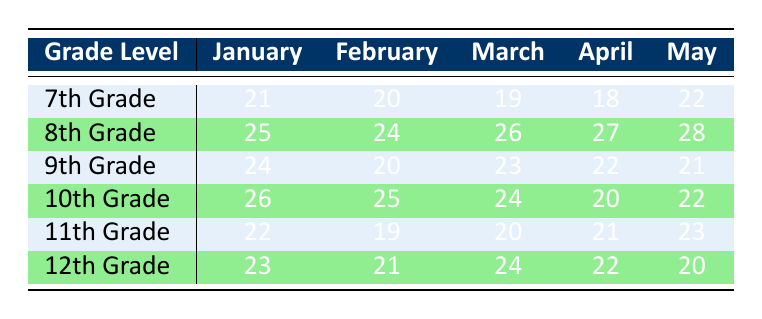What is the attendance of 10th Grade in March? The table shows the attendance values for each grade level. Looking under the 10th Grade row in the March column, the attendance is 24.
Answer: 24 What was the lowest attendance recorded in April? To find the lowest attendance in April, we check the April column for each grade. The attendances are: 18 (7th Grade), 27 (8th Grade), 22 (9th Grade), 20 (10th Grade), 21 (11th Grade), and 22 (12th Grade). The lowest number is 18 from the 7th Grade.
Answer: 18 Which grade had the highest attendance in May? We need to compare the May attendance for each grade. The values are: 22 (7th Grade), 28 (8th Grade), 21 (9th Grade), 22 (10th Grade), 23 (11th Grade), and 20 (12th Grade). The highest is 28 from the 8th Grade.
Answer: 8th Grade What is the average attendance for 9th Grade over the five months? Adding the 9th Grade attendance values: 24 + 20 + 23 + 22 + 21 = 110. To find the average, we divide by the number of months: 110 / 5 = 22.
Answer: 22 True or False: 11th Grade had better attendance than 12th Grade in every month. We need to compare each month for 11th Grade (22, 19, 20, 21, 23) and 12th Grade (23, 21, 24, 22, 20). In January, 11th Grade had 22 (less than 12th Grade's 23), so the statement is false.
Answer: False Which grade had a decrease in attendance from January to April? We compare each grade's attendance from January to April. The values are: 7th Grade (21 to 18), 8th Grade (25 to 27), 9th Grade (24 to 22), 10th Grade (26 to 20), 11th Grade (22 to 21), and 12th Grade (23 to 22). The grades with a decrease are: 7th Grade, 9th Grade, and 10th Grade.
Answer: 7th Grade, 9th Grade, 10th Grade What is the difference in attendance between 8th Grade and 7th Grade in March? We take the values from the March column: 8th Grade has 26 and 7th Grade has 19. The difference is calculated as 26 - 19 = 7.
Answer: 7 Which grade had the highest overall attendance for the year? To determine the highest overall attendance, we sum each grade's attendance: 7th Grade = 100, 8th Grade = 130, 9th Grade = 110, 10th Grade = 117, 11th Grade = 105, and 12th Grade = 110. The highest sum is from the 8th Grade with 130.
Answer: 8th Grade 